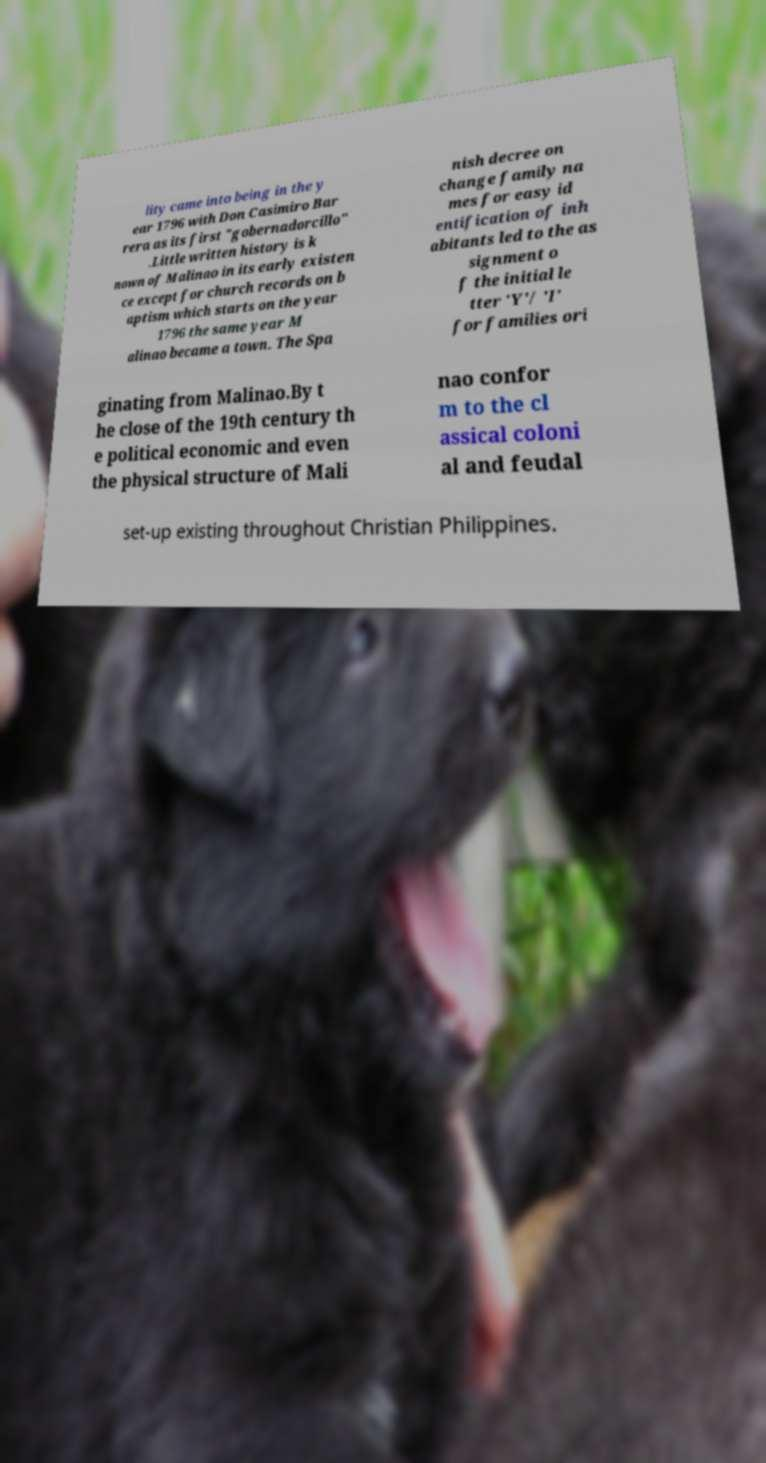Please identify and transcribe the text found in this image. lity came into being in the y ear 1796 with Don Casimiro Bar rera as its first "gobernadorcillo" .Little written history is k nown of Malinao in its early existen ce except for church records on b aptism which starts on the year 1796 the same year M alinao became a town. The Spa nish decree on change family na mes for easy id entification of inh abitants led to the as signment o f the initial le tter 'Y'/ 'I' for families ori ginating from Malinao.By t he close of the 19th century th e political economic and even the physical structure of Mali nao confor m to the cl assical coloni al and feudal set-up existing throughout Christian Philippines. 